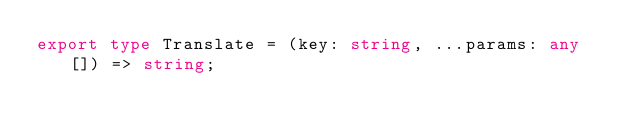<code> <loc_0><loc_0><loc_500><loc_500><_TypeScript_>export type Translate = (key: string, ...params: any[]) => string;
</code> 